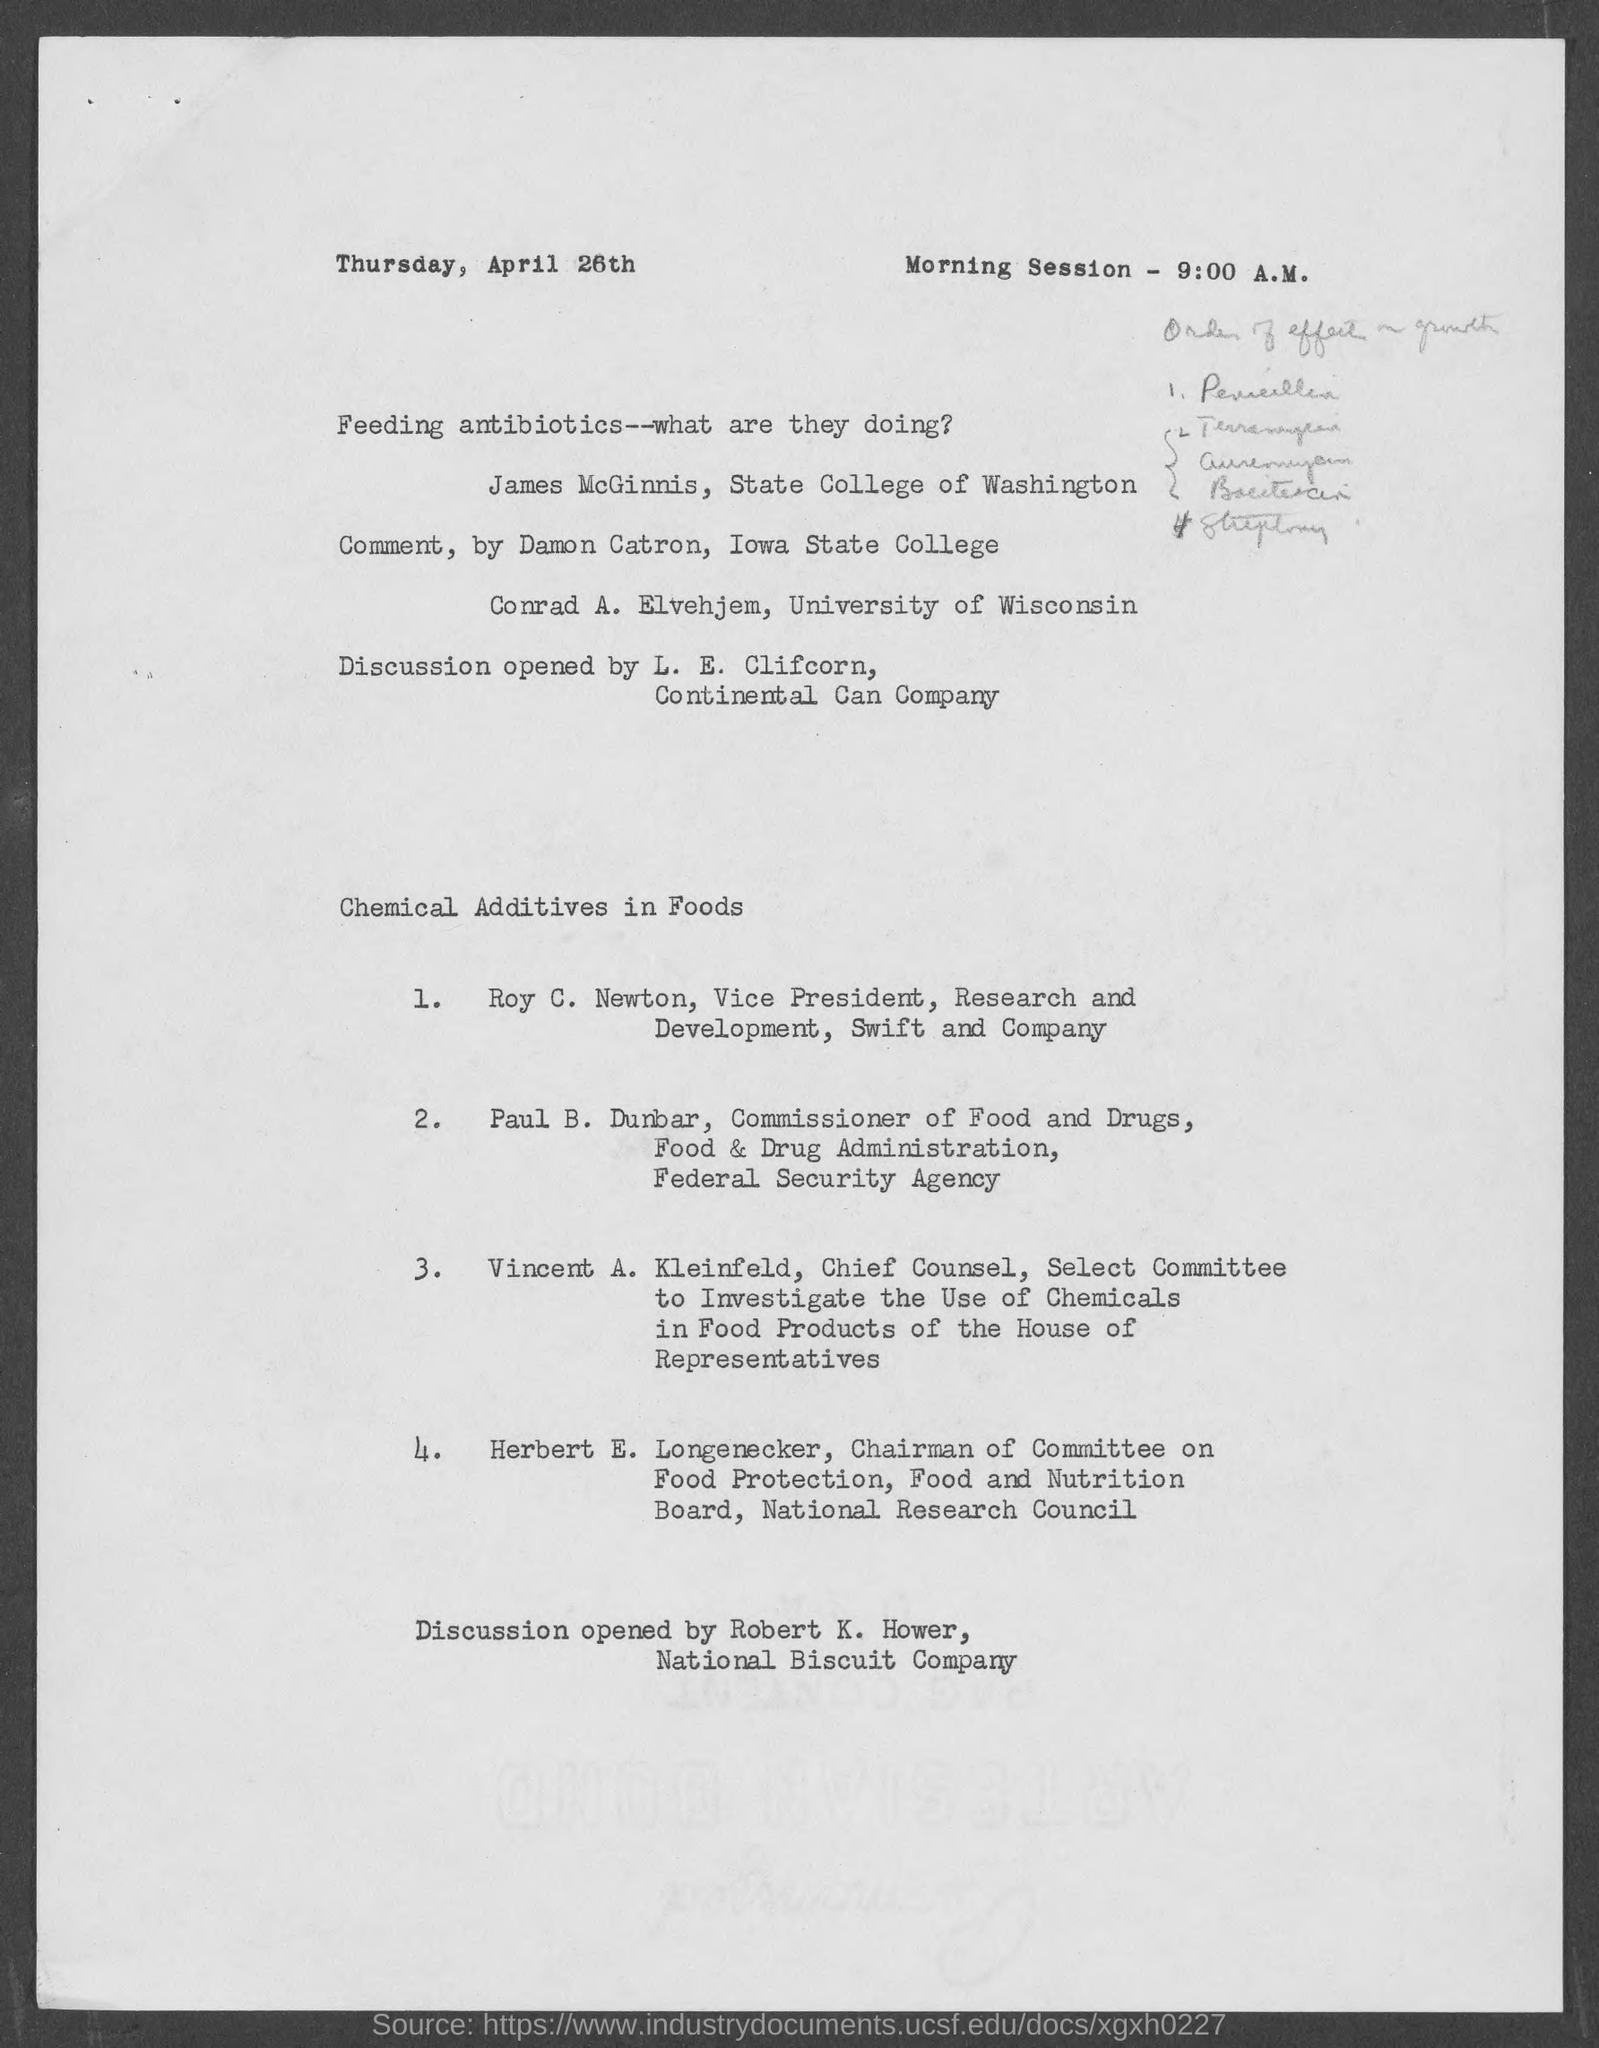What is the date on the document?
Offer a terse response. Thursday, April 26th. When is the Morning session?
Make the answer very short. 9:00 A.M. 